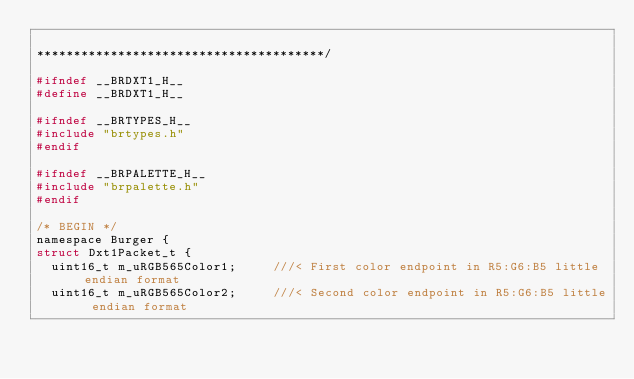Convert code to text. <code><loc_0><loc_0><loc_500><loc_500><_C_>
***************************************/

#ifndef __BRDXT1_H__
#define __BRDXT1_H__

#ifndef __BRTYPES_H__
#include "brtypes.h"
#endif

#ifndef __BRPALETTE_H__
#include "brpalette.h"
#endif

/* BEGIN */
namespace Burger {
struct Dxt1Packet_t {
	uint16_t m_uRGB565Color1;			///< First color endpoint in R5:G6:B5 little endian format
	uint16_t m_uRGB565Color2;			///< Second color endpoint in R5:G6:B5 little endian format</code> 